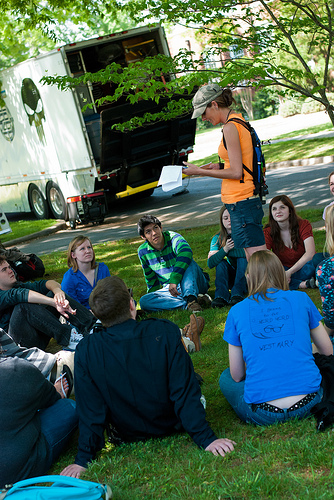<image>
Is the truck behind the girl? Yes. From this viewpoint, the truck is positioned behind the girl, with the girl partially or fully occluding the truck. 